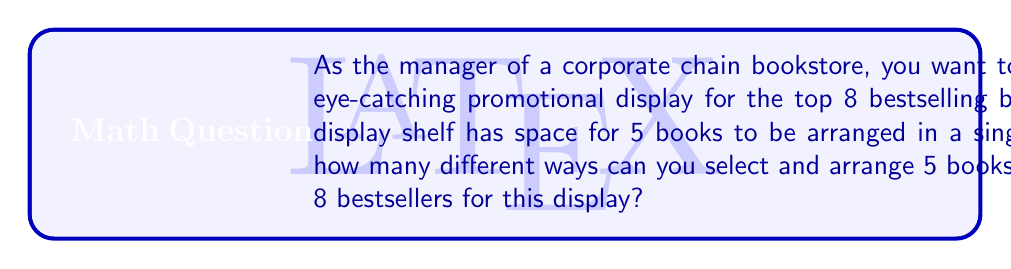Show me your answer to this math problem. To solve this problem, we need to use the concept of permutations. We are selecting 5 books out of 8 and arranging them in a specific order. This is a permutation without repetition.

The formula for permutations without repetition is:

$$P(n,r) = \frac{n!}{(n-r)!}$$

Where:
$n$ = total number of items to choose from
$r$ = number of items being chosen and arranged

In this case:
$n = 8$ (total bestselling books)
$r = 5$ (books to be displayed)

Let's substitute these values into the formula:

$$P(8,5) = \frac{8!}{(8-5)!} = \frac{8!}{3!}$$

Now, let's calculate this step-by-step:

1) $8! = 8 \times 7 \times 6 \times 5 \times 4 \times 3!$
2) $\frac{8!}{3!} = \frac{8 \times 7 \times 6 \times 5 \times 4 \times 3!}{3!}$
3) The $3!$ cancels out in the numerator and denominator
4) $= 8 \times 7 \times 6 \times 5 \times 4$
5) $= 6720$

Therefore, there are 6720 different ways to select and arrange 5 books out of the 8 bestsellers for the display.
Answer: 6720 ways 